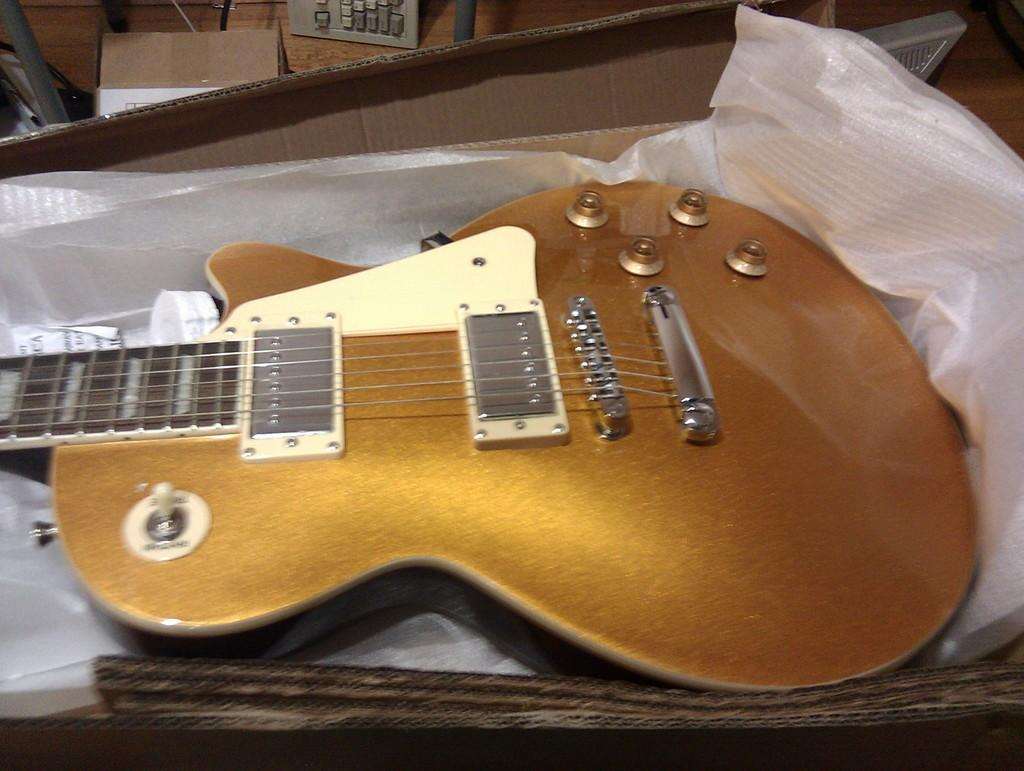What musical instrument is featured in the image? There is a guitar in the image. How was the guitar packaged before being unboxed? The guitar was unboxed from a cardboard box. What is the color of the guitar? The guitar is in a shimmer gold color. What are the guitar's strings like? The guitar has beautiful strings. How many dolls are sitting inside the pail in the image? There are no dolls or pails present in the image; it features a guitar. Can you describe the snails crawling on the guitar strings in the image? There are no snails present on the guitar strings in the image. 